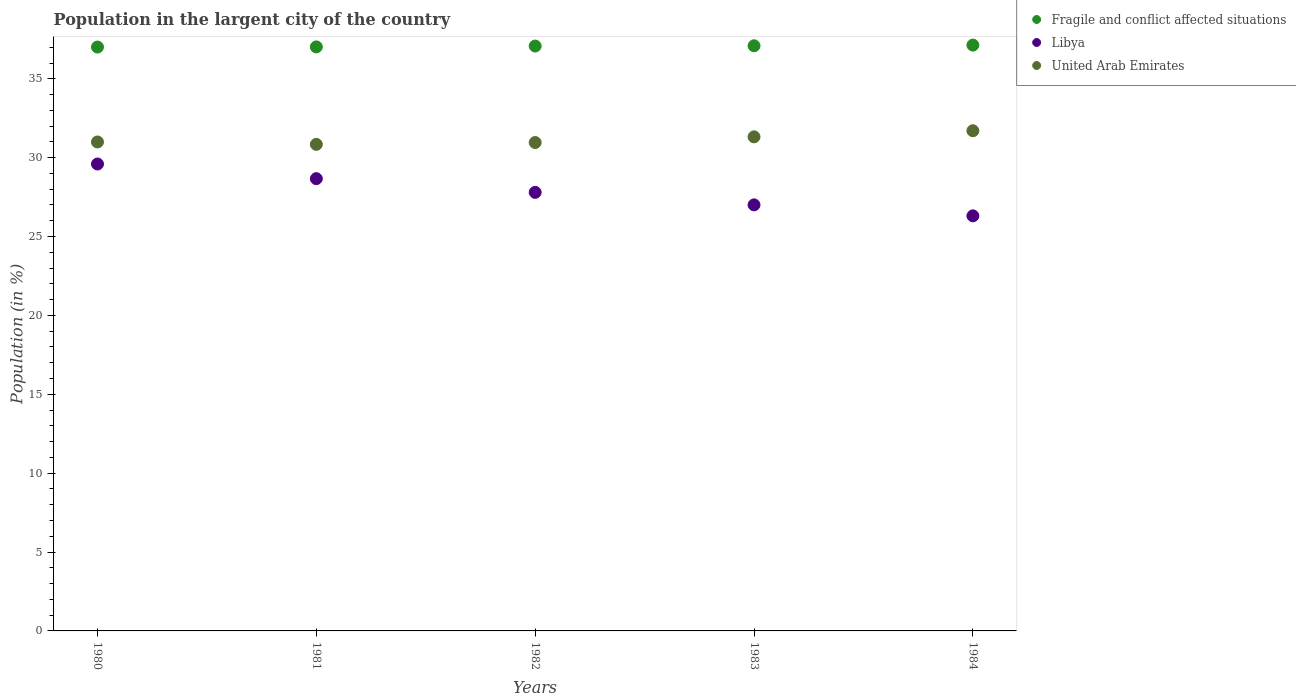How many different coloured dotlines are there?
Ensure brevity in your answer.  3. What is the percentage of population in the largent city in Libya in 1980?
Your answer should be compact. 29.6. Across all years, what is the maximum percentage of population in the largent city in Libya?
Keep it short and to the point. 29.6. Across all years, what is the minimum percentage of population in the largent city in United Arab Emirates?
Make the answer very short. 30.84. In which year was the percentage of population in the largent city in United Arab Emirates minimum?
Provide a short and direct response. 1981. What is the total percentage of population in the largent city in United Arab Emirates in the graph?
Your answer should be very brief. 155.83. What is the difference between the percentage of population in the largent city in Fragile and conflict affected situations in 1981 and that in 1983?
Provide a succinct answer. -0.07. What is the difference between the percentage of population in the largent city in Fragile and conflict affected situations in 1984 and the percentage of population in the largent city in United Arab Emirates in 1983?
Provide a short and direct response. 5.82. What is the average percentage of population in the largent city in Fragile and conflict affected situations per year?
Offer a very short reply. 37.07. In the year 1981, what is the difference between the percentage of population in the largent city in United Arab Emirates and percentage of population in the largent city in Fragile and conflict affected situations?
Your answer should be very brief. -6.18. In how many years, is the percentage of population in the largent city in United Arab Emirates greater than 6 %?
Your answer should be very brief. 5. What is the ratio of the percentage of population in the largent city in United Arab Emirates in 1981 to that in 1984?
Provide a short and direct response. 0.97. What is the difference between the highest and the second highest percentage of population in the largent city in Libya?
Give a very brief answer. 0.93. What is the difference between the highest and the lowest percentage of population in the largent city in Libya?
Offer a very short reply. 3.29. In how many years, is the percentage of population in the largent city in Libya greater than the average percentage of population in the largent city in Libya taken over all years?
Give a very brief answer. 2. Is it the case that in every year, the sum of the percentage of population in the largent city in Fragile and conflict affected situations and percentage of population in the largent city in Libya  is greater than the percentage of population in the largent city in United Arab Emirates?
Ensure brevity in your answer.  Yes. Does the percentage of population in the largent city in United Arab Emirates monotonically increase over the years?
Provide a succinct answer. No. Is the percentage of population in the largent city in Libya strictly greater than the percentage of population in the largent city in Fragile and conflict affected situations over the years?
Give a very brief answer. No. Is the percentage of population in the largent city in United Arab Emirates strictly less than the percentage of population in the largent city in Libya over the years?
Offer a very short reply. No. How many years are there in the graph?
Provide a succinct answer. 5. What is the difference between two consecutive major ticks on the Y-axis?
Offer a terse response. 5. Does the graph contain grids?
Keep it short and to the point. No. Where does the legend appear in the graph?
Give a very brief answer. Top right. How are the legend labels stacked?
Offer a very short reply. Vertical. What is the title of the graph?
Offer a very short reply. Population in the largent city of the country. What is the label or title of the X-axis?
Your answer should be compact. Years. What is the Population (in %) of Fragile and conflict affected situations in 1980?
Your answer should be compact. 37.01. What is the Population (in %) in Libya in 1980?
Make the answer very short. 29.6. What is the Population (in %) in United Arab Emirates in 1980?
Keep it short and to the point. 31. What is the Population (in %) in Fragile and conflict affected situations in 1981?
Your answer should be very brief. 37.02. What is the Population (in %) of Libya in 1981?
Provide a succinct answer. 28.67. What is the Population (in %) of United Arab Emirates in 1981?
Your response must be concise. 30.84. What is the Population (in %) of Fragile and conflict affected situations in 1982?
Provide a short and direct response. 37.08. What is the Population (in %) in Libya in 1982?
Your answer should be very brief. 27.8. What is the Population (in %) in United Arab Emirates in 1982?
Offer a terse response. 30.96. What is the Population (in %) of Fragile and conflict affected situations in 1983?
Keep it short and to the point. 37.09. What is the Population (in %) in Libya in 1983?
Offer a terse response. 27.01. What is the Population (in %) of United Arab Emirates in 1983?
Offer a terse response. 31.32. What is the Population (in %) in Fragile and conflict affected situations in 1984?
Keep it short and to the point. 37.14. What is the Population (in %) in Libya in 1984?
Provide a short and direct response. 26.31. What is the Population (in %) in United Arab Emirates in 1984?
Provide a short and direct response. 31.71. Across all years, what is the maximum Population (in %) of Fragile and conflict affected situations?
Keep it short and to the point. 37.14. Across all years, what is the maximum Population (in %) in Libya?
Offer a terse response. 29.6. Across all years, what is the maximum Population (in %) in United Arab Emirates?
Your answer should be very brief. 31.71. Across all years, what is the minimum Population (in %) of Fragile and conflict affected situations?
Make the answer very short. 37.01. Across all years, what is the minimum Population (in %) of Libya?
Your answer should be compact. 26.31. Across all years, what is the minimum Population (in %) in United Arab Emirates?
Make the answer very short. 30.84. What is the total Population (in %) of Fragile and conflict affected situations in the graph?
Provide a succinct answer. 185.34. What is the total Population (in %) of Libya in the graph?
Provide a succinct answer. 139.39. What is the total Population (in %) of United Arab Emirates in the graph?
Your answer should be very brief. 155.83. What is the difference between the Population (in %) of Fragile and conflict affected situations in 1980 and that in 1981?
Offer a terse response. -0.01. What is the difference between the Population (in %) of Libya in 1980 and that in 1981?
Offer a very short reply. 0.93. What is the difference between the Population (in %) of United Arab Emirates in 1980 and that in 1981?
Provide a succinct answer. 0.15. What is the difference between the Population (in %) of Fragile and conflict affected situations in 1980 and that in 1982?
Your answer should be very brief. -0.06. What is the difference between the Population (in %) in Libya in 1980 and that in 1982?
Make the answer very short. 1.8. What is the difference between the Population (in %) of United Arab Emirates in 1980 and that in 1982?
Your response must be concise. 0.04. What is the difference between the Population (in %) of Fragile and conflict affected situations in 1980 and that in 1983?
Give a very brief answer. -0.08. What is the difference between the Population (in %) in Libya in 1980 and that in 1983?
Provide a succinct answer. 2.59. What is the difference between the Population (in %) in United Arab Emirates in 1980 and that in 1983?
Your answer should be compact. -0.32. What is the difference between the Population (in %) in Fragile and conflict affected situations in 1980 and that in 1984?
Provide a succinct answer. -0.12. What is the difference between the Population (in %) of Libya in 1980 and that in 1984?
Your answer should be very brief. 3.29. What is the difference between the Population (in %) of United Arab Emirates in 1980 and that in 1984?
Offer a terse response. -0.71. What is the difference between the Population (in %) of Fragile and conflict affected situations in 1981 and that in 1982?
Offer a very short reply. -0.05. What is the difference between the Population (in %) of Libya in 1981 and that in 1982?
Provide a succinct answer. 0.87. What is the difference between the Population (in %) in United Arab Emirates in 1981 and that in 1982?
Ensure brevity in your answer.  -0.12. What is the difference between the Population (in %) of Fragile and conflict affected situations in 1981 and that in 1983?
Provide a short and direct response. -0.07. What is the difference between the Population (in %) in Libya in 1981 and that in 1983?
Your answer should be compact. 1.66. What is the difference between the Population (in %) in United Arab Emirates in 1981 and that in 1983?
Your response must be concise. -0.48. What is the difference between the Population (in %) of Fragile and conflict affected situations in 1981 and that in 1984?
Give a very brief answer. -0.11. What is the difference between the Population (in %) of Libya in 1981 and that in 1984?
Offer a very short reply. 2.36. What is the difference between the Population (in %) in United Arab Emirates in 1981 and that in 1984?
Make the answer very short. -0.86. What is the difference between the Population (in %) in Fragile and conflict affected situations in 1982 and that in 1983?
Offer a terse response. -0.02. What is the difference between the Population (in %) in Libya in 1982 and that in 1983?
Provide a succinct answer. 0.79. What is the difference between the Population (in %) in United Arab Emirates in 1982 and that in 1983?
Provide a succinct answer. -0.36. What is the difference between the Population (in %) in Fragile and conflict affected situations in 1982 and that in 1984?
Ensure brevity in your answer.  -0.06. What is the difference between the Population (in %) of Libya in 1982 and that in 1984?
Give a very brief answer. 1.49. What is the difference between the Population (in %) in United Arab Emirates in 1982 and that in 1984?
Your answer should be very brief. -0.75. What is the difference between the Population (in %) of Fragile and conflict affected situations in 1983 and that in 1984?
Provide a short and direct response. -0.04. What is the difference between the Population (in %) of Libya in 1983 and that in 1984?
Keep it short and to the point. 0.7. What is the difference between the Population (in %) in United Arab Emirates in 1983 and that in 1984?
Offer a very short reply. -0.39. What is the difference between the Population (in %) in Fragile and conflict affected situations in 1980 and the Population (in %) in Libya in 1981?
Offer a terse response. 8.34. What is the difference between the Population (in %) in Fragile and conflict affected situations in 1980 and the Population (in %) in United Arab Emirates in 1981?
Your answer should be very brief. 6.17. What is the difference between the Population (in %) of Libya in 1980 and the Population (in %) of United Arab Emirates in 1981?
Offer a terse response. -1.25. What is the difference between the Population (in %) in Fragile and conflict affected situations in 1980 and the Population (in %) in Libya in 1982?
Provide a succinct answer. 9.21. What is the difference between the Population (in %) in Fragile and conflict affected situations in 1980 and the Population (in %) in United Arab Emirates in 1982?
Provide a short and direct response. 6.05. What is the difference between the Population (in %) in Libya in 1980 and the Population (in %) in United Arab Emirates in 1982?
Provide a succinct answer. -1.36. What is the difference between the Population (in %) of Fragile and conflict affected situations in 1980 and the Population (in %) of Libya in 1983?
Keep it short and to the point. 10. What is the difference between the Population (in %) of Fragile and conflict affected situations in 1980 and the Population (in %) of United Arab Emirates in 1983?
Provide a succinct answer. 5.69. What is the difference between the Population (in %) in Libya in 1980 and the Population (in %) in United Arab Emirates in 1983?
Make the answer very short. -1.72. What is the difference between the Population (in %) of Fragile and conflict affected situations in 1980 and the Population (in %) of Libya in 1984?
Keep it short and to the point. 10.7. What is the difference between the Population (in %) in Fragile and conflict affected situations in 1980 and the Population (in %) in United Arab Emirates in 1984?
Make the answer very short. 5.31. What is the difference between the Population (in %) in Libya in 1980 and the Population (in %) in United Arab Emirates in 1984?
Your response must be concise. -2.11. What is the difference between the Population (in %) of Fragile and conflict affected situations in 1981 and the Population (in %) of Libya in 1982?
Provide a succinct answer. 9.22. What is the difference between the Population (in %) in Fragile and conflict affected situations in 1981 and the Population (in %) in United Arab Emirates in 1982?
Give a very brief answer. 6.06. What is the difference between the Population (in %) in Libya in 1981 and the Population (in %) in United Arab Emirates in 1982?
Ensure brevity in your answer.  -2.29. What is the difference between the Population (in %) of Fragile and conflict affected situations in 1981 and the Population (in %) of Libya in 1983?
Offer a terse response. 10.01. What is the difference between the Population (in %) of Fragile and conflict affected situations in 1981 and the Population (in %) of United Arab Emirates in 1983?
Your answer should be very brief. 5.7. What is the difference between the Population (in %) of Libya in 1981 and the Population (in %) of United Arab Emirates in 1983?
Make the answer very short. -2.65. What is the difference between the Population (in %) of Fragile and conflict affected situations in 1981 and the Population (in %) of Libya in 1984?
Give a very brief answer. 10.71. What is the difference between the Population (in %) in Fragile and conflict affected situations in 1981 and the Population (in %) in United Arab Emirates in 1984?
Keep it short and to the point. 5.32. What is the difference between the Population (in %) in Libya in 1981 and the Population (in %) in United Arab Emirates in 1984?
Your answer should be compact. -3.04. What is the difference between the Population (in %) in Fragile and conflict affected situations in 1982 and the Population (in %) in Libya in 1983?
Provide a succinct answer. 10.07. What is the difference between the Population (in %) in Fragile and conflict affected situations in 1982 and the Population (in %) in United Arab Emirates in 1983?
Keep it short and to the point. 5.76. What is the difference between the Population (in %) of Libya in 1982 and the Population (in %) of United Arab Emirates in 1983?
Keep it short and to the point. -3.52. What is the difference between the Population (in %) of Fragile and conflict affected situations in 1982 and the Population (in %) of Libya in 1984?
Keep it short and to the point. 10.76. What is the difference between the Population (in %) of Fragile and conflict affected situations in 1982 and the Population (in %) of United Arab Emirates in 1984?
Give a very brief answer. 5.37. What is the difference between the Population (in %) of Libya in 1982 and the Population (in %) of United Arab Emirates in 1984?
Keep it short and to the point. -3.91. What is the difference between the Population (in %) in Fragile and conflict affected situations in 1983 and the Population (in %) in Libya in 1984?
Offer a very short reply. 10.78. What is the difference between the Population (in %) of Fragile and conflict affected situations in 1983 and the Population (in %) of United Arab Emirates in 1984?
Provide a succinct answer. 5.39. What is the difference between the Population (in %) of Libya in 1983 and the Population (in %) of United Arab Emirates in 1984?
Offer a terse response. -4.7. What is the average Population (in %) in Fragile and conflict affected situations per year?
Ensure brevity in your answer.  37.07. What is the average Population (in %) in Libya per year?
Offer a very short reply. 27.88. What is the average Population (in %) in United Arab Emirates per year?
Offer a terse response. 31.17. In the year 1980, what is the difference between the Population (in %) in Fragile and conflict affected situations and Population (in %) in Libya?
Your response must be concise. 7.41. In the year 1980, what is the difference between the Population (in %) in Fragile and conflict affected situations and Population (in %) in United Arab Emirates?
Your answer should be very brief. 6.02. In the year 1980, what is the difference between the Population (in %) of Libya and Population (in %) of United Arab Emirates?
Provide a short and direct response. -1.4. In the year 1981, what is the difference between the Population (in %) of Fragile and conflict affected situations and Population (in %) of Libya?
Provide a short and direct response. 8.35. In the year 1981, what is the difference between the Population (in %) of Fragile and conflict affected situations and Population (in %) of United Arab Emirates?
Offer a terse response. 6.18. In the year 1981, what is the difference between the Population (in %) in Libya and Population (in %) in United Arab Emirates?
Your response must be concise. -2.17. In the year 1982, what is the difference between the Population (in %) of Fragile and conflict affected situations and Population (in %) of Libya?
Provide a succinct answer. 9.28. In the year 1982, what is the difference between the Population (in %) of Fragile and conflict affected situations and Population (in %) of United Arab Emirates?
Your response must be concise. 6.12. In the year 1982, what is the difference between the Population (in %) of Libya and Population (in %) of United Arab Emirates?
Give a very brief answer. -3.16. In the year 1983, what is the difference between the Population (in %) in Fragile and conflict affected situations and Population (in %) in Libya?
Your response must be concise. 10.08. In the year 1983, what is the difference between the Population (in %) in Fragile and conflict affected situations and Population (in %) in United Arab Emirates?
Your response must be concise. 5.77. In the year 1983, what is the difference between the Population (in %) in Libya and Population (in %) in United Arab Emirates?
Provide a succinct answer. -4.31. In the year 1984, what is the difference between the Population (in %) in Fragile and conflict affected situations and Population (in %) in Libya?
Your answer should be compact. 10.82. In the year 1984, what is the difference between the Population (in %) in Fragile and conflict affected situations and Population (in %) in United Arab Emirates?
Your answer should be very brief. 5.43. In the year 1984, what is the difference between the Population (in %) of Libya and Population (in %) of United Arab Emirates?
Your response must be concise. -5.39. What is the ratio of the Population (in %) in Fragile and conflict affected situations in 1980 to that in 1981?
Make the answer very short. 1. What is the ratio of the Population (in %) of Libya in 1980 to that in 1981?
Offer a terse response. 1.03. What is the ratio of the Population (in %) of United Arab Emirates in 1980 to that in 1981?
Provide a succinct answer. 1. What is the ratio of the Population (in %) in Fragile and conflict affected situations in 1980 to that in 1982?
Offer a very short reply. 1. What is the ratio of the Population (in %) of Libya in 1980 to that in 1982?
Provide a short and direct response. 1.06. What is the ratio of the Population (in %) of Libya in 1980 to that in 1983?
Offer a terse response. 1.1. What is the ratio of the Population (in %) of Libya in 1980 to that in 1984?
Your answer should be very brief. 1.12. What is the ratio of the Population (in %) in United Arab Emirates in 1980 to that in 1984?
Your answer should be very brief. 0.98. What is the ratio of the Population (in %) of Fragile and conflict affected situations in 1981 to that in 1982?
Your answer should be compact. 1. What is the ratio of the Population (in %) of Libya in 1981 to that in 1982?
Ensure brevity in your answer.  1.03. What is the ratio of the Population (in %) in United Arab Emirates in 1981 to that in 1982?
Give a very brief answer. 1. What is the ratio of the Population (in %) in Fragile and conflict affected situations in 1981 to that in 1983?
Your answer should be compact. 1. What is the ratio of the Population (in %) in Libya in 1981 to that in 1983?
Provide a succinct answer. 1.06. What is the ratio of the Population (in %) in United Arab Emirates in 1981 to that in 1983?
Offer a very short reply. 0.98. What is the ratio of the Population (in %) of Libya in 1981 to that in 1984?
Give a very brief answer. 1.09. What is the ratio of the Population (in %) of United Arab Emirates in 1981 to that in 1984?
Offer a very short reply. 0.97. What is the ratio of the Population (in %) of Fragile and conflict affected situations in 1982 to that in 1983?
Your response must be concise. 1. What is the ratio of the Population (in %) of Libya in 1982 to that in 1983?
Keep it short and to the point. 1.03. What is the ratio of the Population (in %) in Libya in 1982 to that in 1984?
Offer a terse response. 1.06. What is the ratio of the Population (in %) in United Arab Emirates in 1982 to that in 1984?
Make the answer very short. 0.98. What is the ratio of the Population (in %) in Fragile and conflict affected situations in 1983 to that in 1984?
Keep it short and to the point. 1. What is the ratio of the Population (in %) of Libya in 1983 to that in 1984?
Give a very brief answer. 1.03. What is the ratio of the Population (in %) of United Arab Emirates in 1983 to that in 1984?
Offer a very short reply. 0.99. What is the difference between the highest and the second highest Population (in %) of Fragile and conflict affected situations?
Your answer should be compact. 0.04. What is the difference between the highest and the second highest Population (in %) in Libya?
Your answer should be compact. 0.93. What is the difference between the highest and the second highest Population (in %) of United Arab Emirates?
Your answer should be very brief. 0.39. What is the difference between the highest and the lowest Population (in %) in Fragile and conflict affected situations?
Keep it short and to the point. 0.12. What is the difference between the highest and the lowest Population (in %) in Libya?
Your response must be concise. 3.29. What is the difference between the highest and the lowest Population (in %) in United Arab Emirates?
Keep it short and to the point. 0.86. 